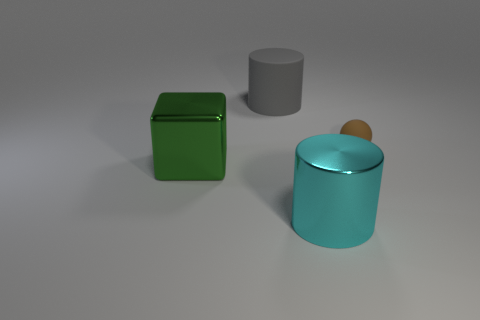Subtract all gray cylinders. How many cylinders are left? 1 Add 3 metallic blocks. How many objects exist? 7 Subtract all cubes. How many objects are left? 3 Subtract 1 blocks. How many blocks are left? 0 Add 3 big cyan cylinders. How many big cyan cylinders are left? 4 Add 3 matte objects. How many matte objects exist? 5 Subtract 0 gray balls. How many objects are left? 4 Subtract all blue balls. Subtract all brown cylinders. How many balls are left? 1 Subtract all green cylinders. How many red spheres are left? 0 Subtract all big brown objects. Subtract all tiny spheres. How many objects are left? 3 